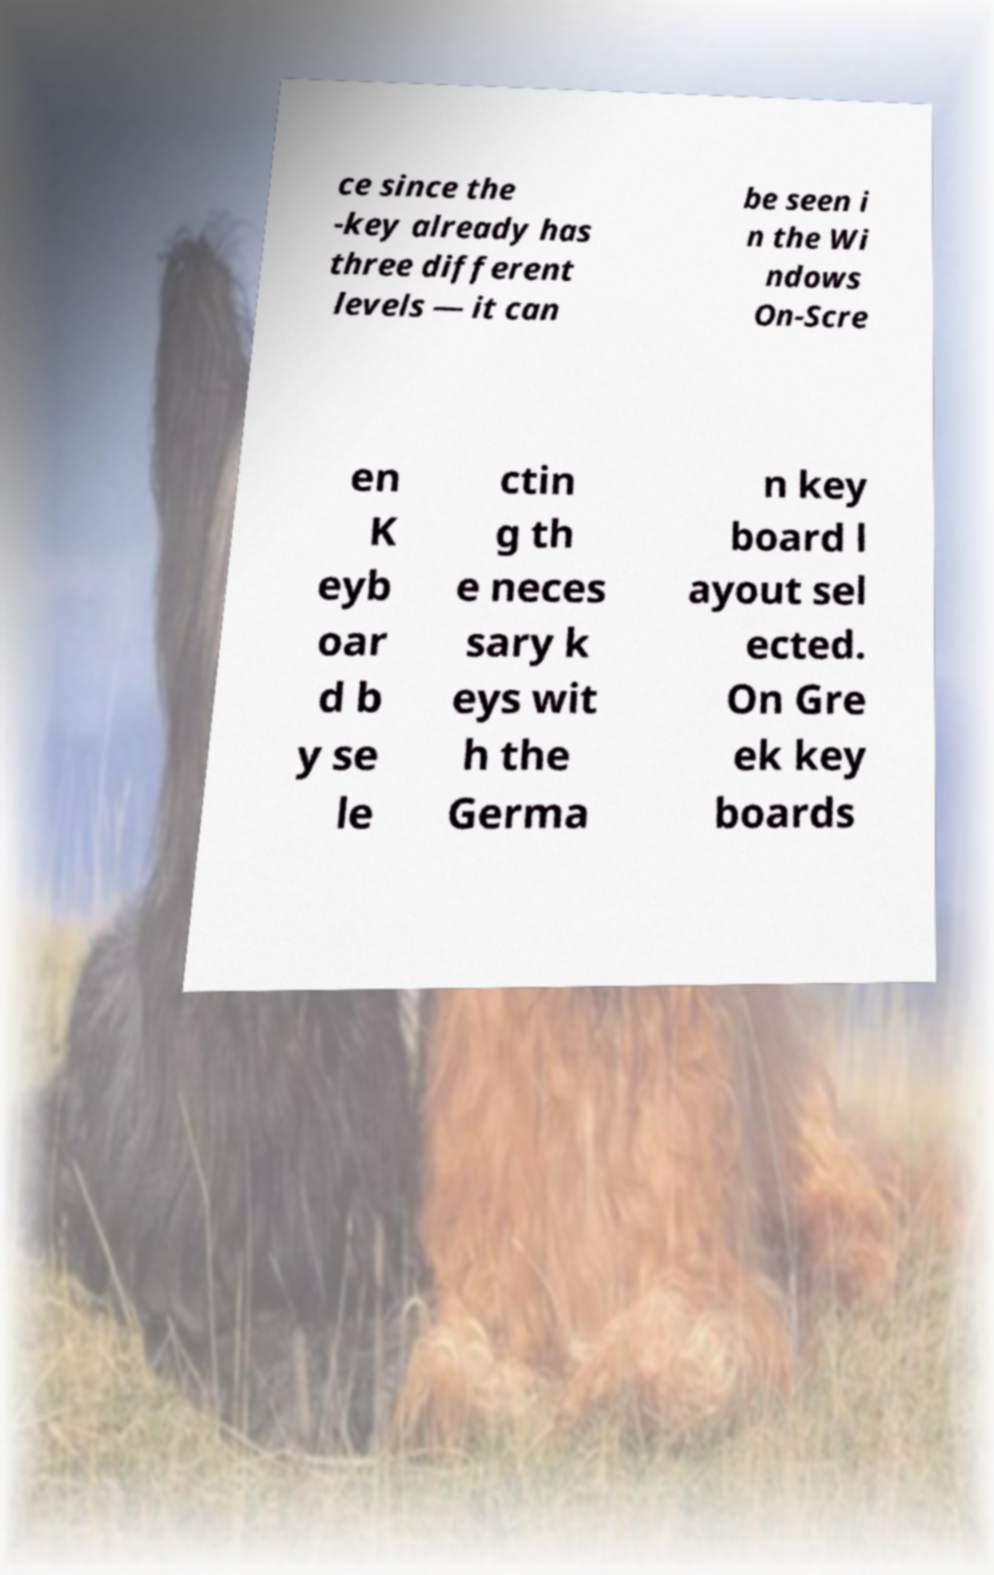Can you read and provide the text displayed in the image?This photo seems to have some interesting text. Can you extract and type it out for me? ce since the -key already has three different levels — it can be seen i n the Wi ndows On-Scre en K eyb oar d b y se le ctin g th e neces sary k eys wit h the Germa n key board l ayout sel ected. On Gre ek key boards 